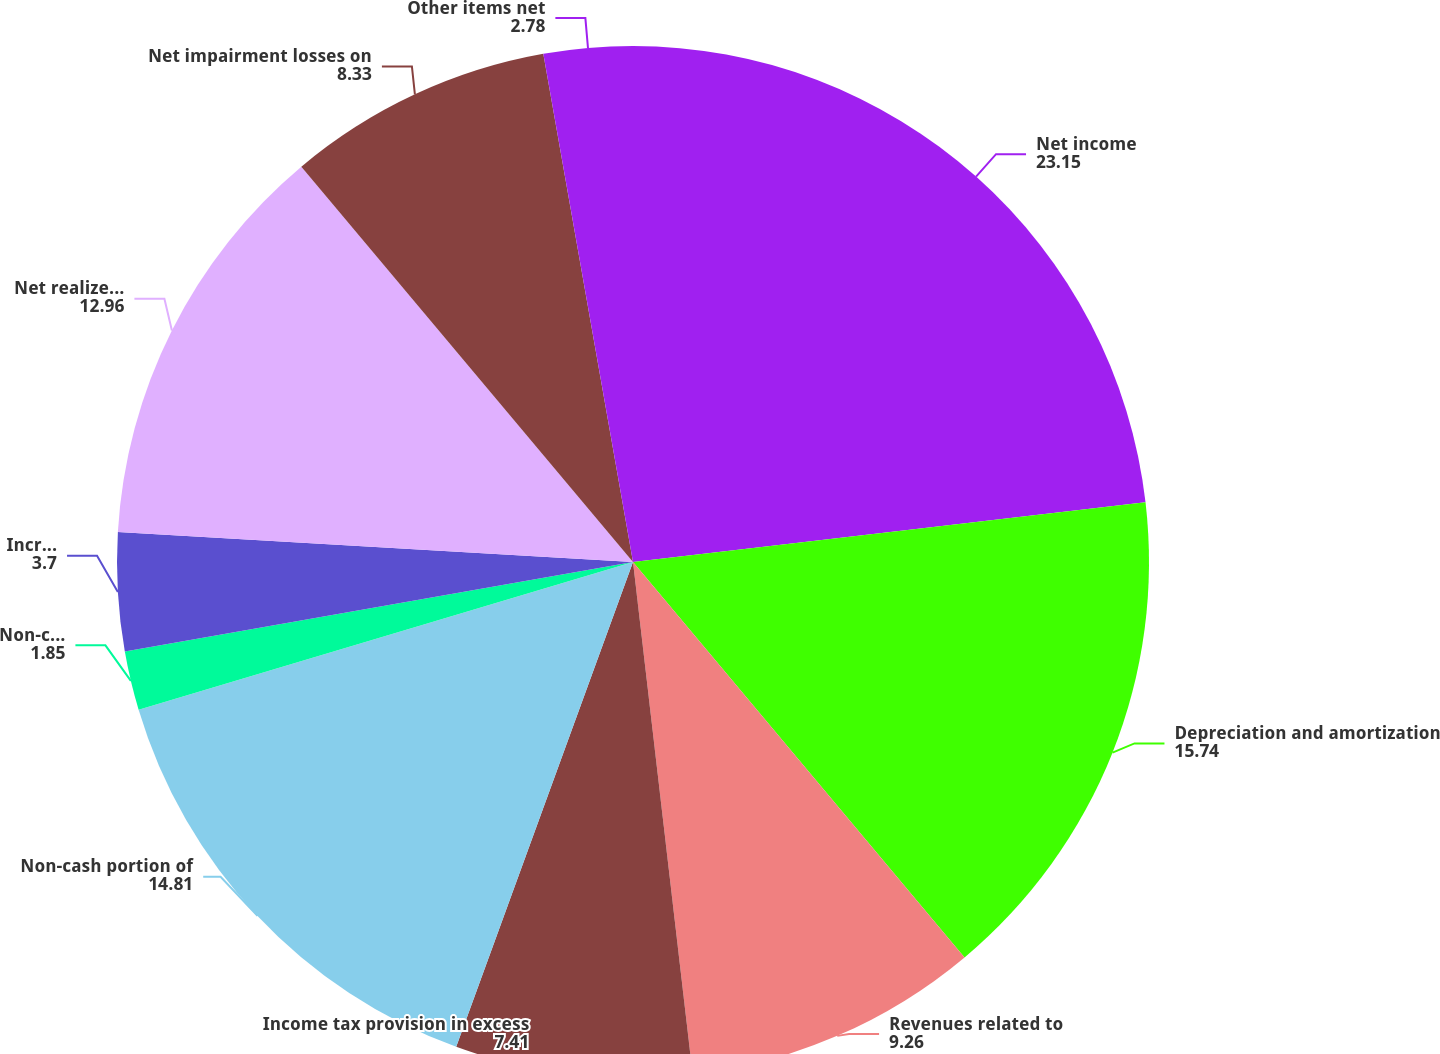<chart> <loc_0><loc_0><loc_500><loc_500><pie_chart><fcel>Net income<fcel>Depreciation and amortization<fcel>Revenues related to<fcel>Income tax provision in excess<fcel>Non-cash portion of<fcel>Non-cash portion of interest<fcel>Incremental tax benefit from<fcel>Net realized gains on<fcel>Net impairment losses on<fcel>Other items net<nl><fcel>23.15%<fcel>15.74%<fcel>9.26%<fcel>7.41%<fcel>14.81%<fcel>1.85%<fcel>3.7%<fcel>12.96%<fcel>8.33%<fcel>2.78%<nl></chart> 